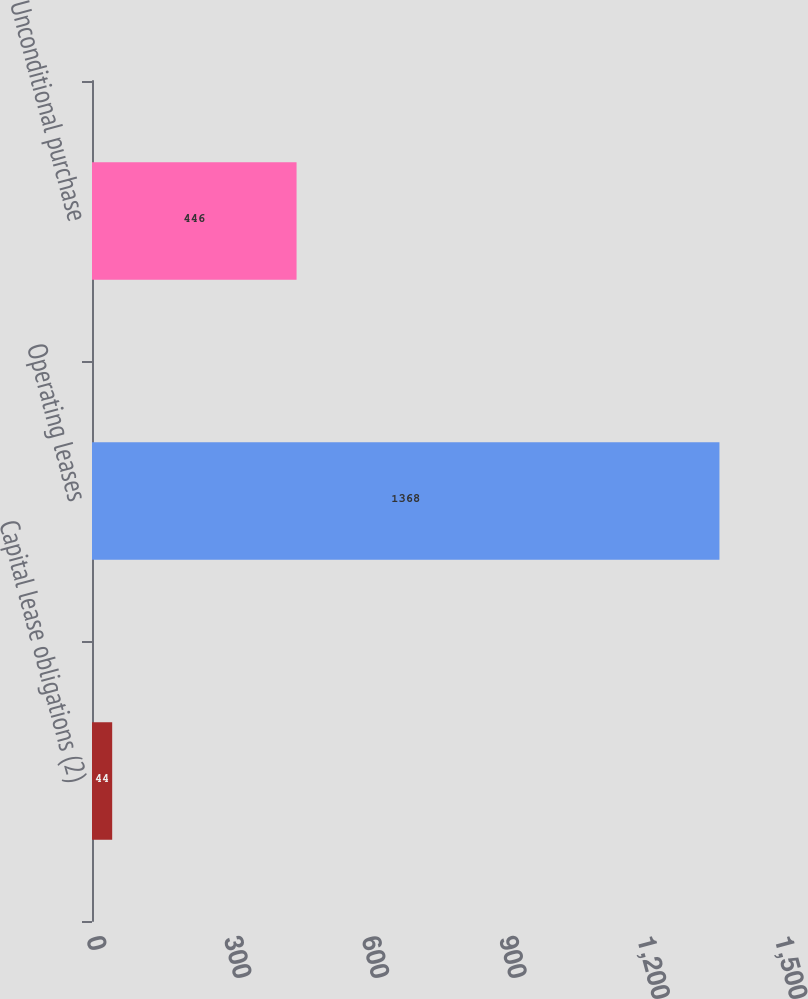Convert chart. <chart><loc_0><loc_0><loc_500><loc_500><bar_chart><fcel>Capital lease obligations (2)<fcel>Operating leases<fcel>Unconditional purchase<nl><fcel>44<fcel>1368<fcel>446<nl></chart> 